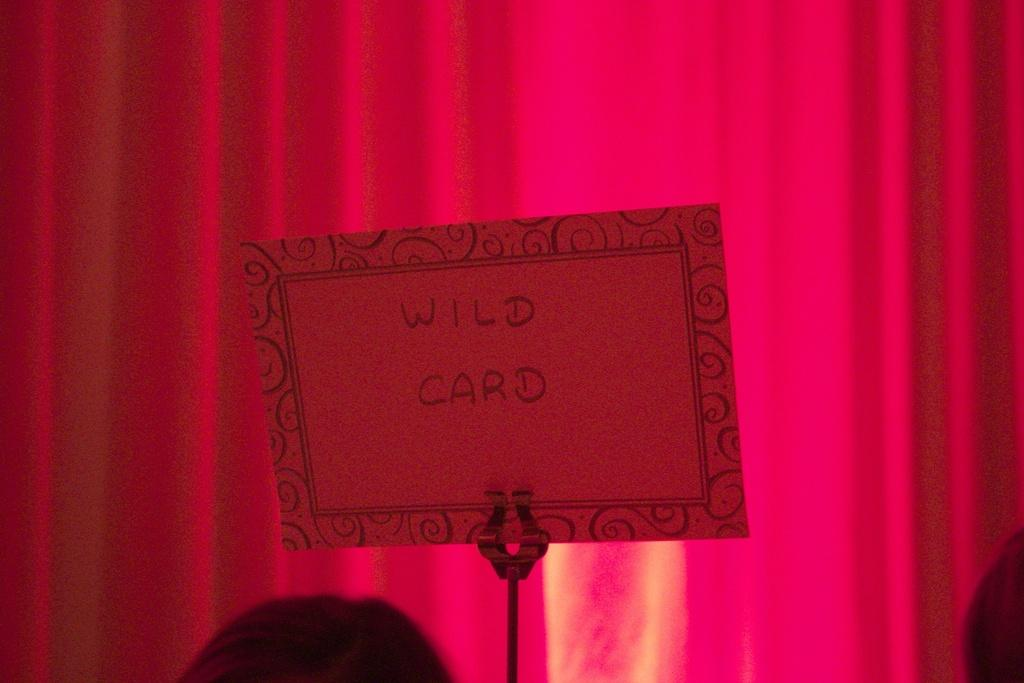What is present on the paper in the image? The word "WILD CARD" is written on the paper. Can you describe the background of the image? There is a pink color curtain in the background of the image. What type of prose can be seen on the paper in the image? There is no prose present on the paper in the image; it only has the words "WILD CARD" written on it. What observation can be made about the game being played in the image? There is no game being played in the image; it only features a paper with the words "WILD CARD" and a pink curtain in the background. 